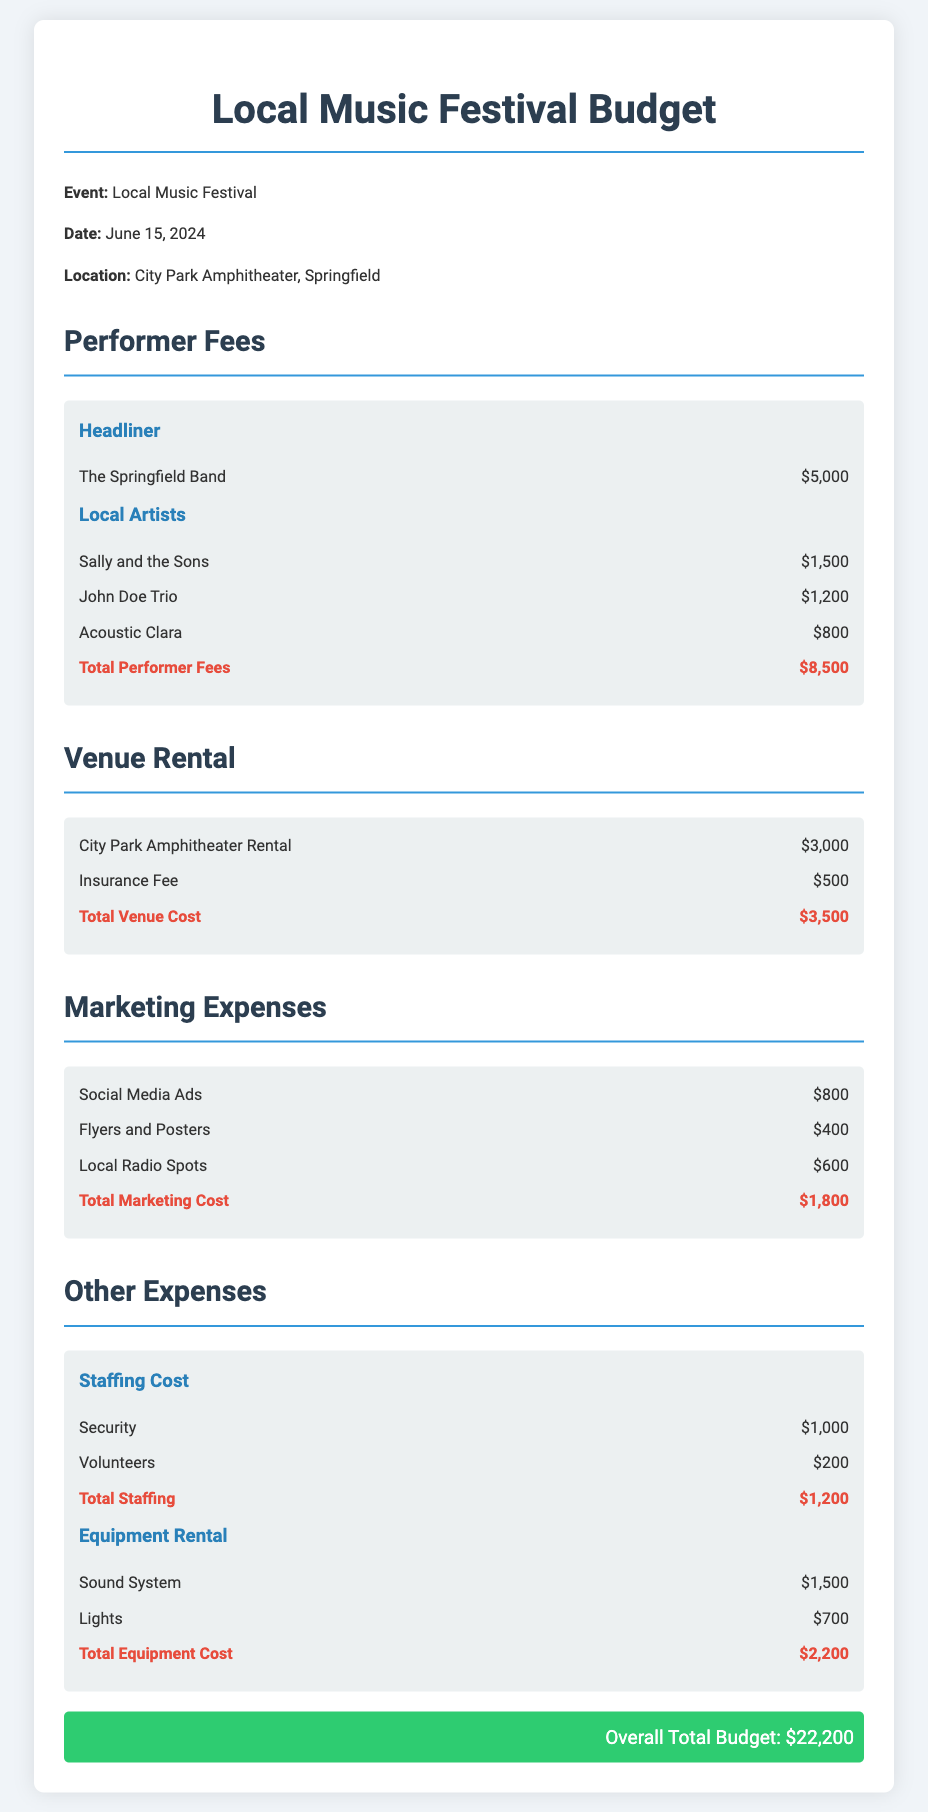What is the date of the event? The date of the event is specified in the document as June 15, 2024.
Answer: June 15, 2024 Who is the headliner for the festival? The headliner is mentioned as The Springfield Band in the performer fees section.
Answer: The Springfield Band What is the total cost for performer fees? The total cost for performer fees is aggregated from all listed performers, totaling $8,500.
Answer: $8,500 How much does the City Park Amphitheater cost to rent? The venue rental cost is explicitly stated as $3,000 in the budget.
Answer: $3,000 What is the total marketing cost? The document provides a summation in the marketing expenses section, amounting to $1,800.
Answer: $1,800 What are the total staffing costs? Total staffing costs contribute $1,200, combining security and volunteer expenses.
Answer: $1,200 What percentage of the overall budget is allocated to performer fees? Calculating the percentage involves dividing performer fees by overall total budget: $8,500 / $22,200 * 100, which gives approximately 38.3%.
Answer: 38.3% What is the total budget for the event? The overall total budget is clearly indicated in the document as $22,200.
Answer: $22,200 How much is spent on local radio spots? The budget lists the cost for local radio spots specifically as $600.
Answer: $600 